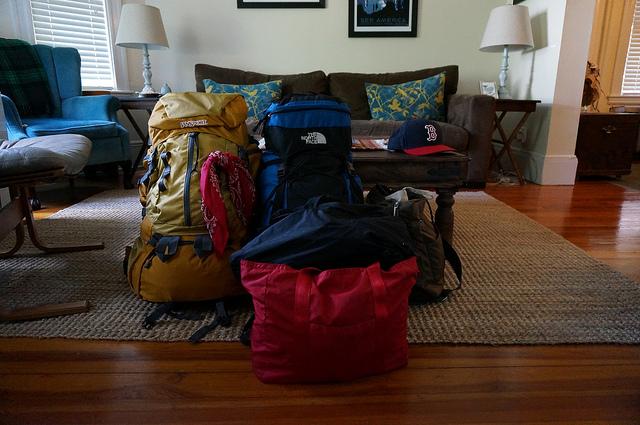What is the window covering?
Concise answer only. Blinds. How can you tell it might be close to Christmas?
Quick response, please. No. What team logo is on the baseball cap?
Be succinct. Boston. What kind of floor is there?
Quick response, please. Wood. How many bags are on the ground?
Short answer required. 5. Is there a trip being planned?
Write a very short answer. Yes. 